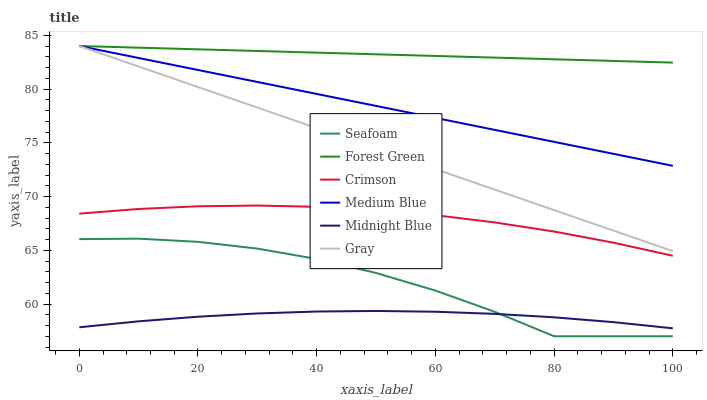Does Medium Blue have the minimum area under the curve?
Answer yes or no. No. Does Medium Blue have the maximum area under the curve?
Answer yes or no. No. Is Midnight Blue the smoothest?
Answer yes or no. No. Is Midnight Blue the roughest?
Answer yes or no. No. Does Midnight Blue have the lowest value?
Answer yes or no. No. Does Midnight Blue have the highest value?
Answer yes or no. No. Is Midnight Blue less than Medium Blue?
Answer yes or no. Yes. Is Medium Blue greater than Crimson?
Answer yes or no. Yes. Does Midnight Blue intersect Medium Blue?
Answer yes or no. No. 